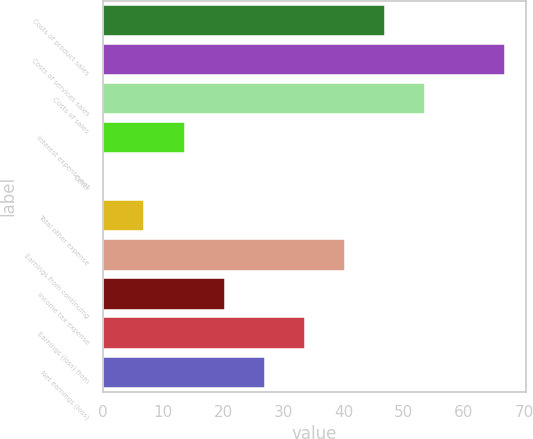<chart> <loc_0><loc_0><loc_500><loc_500><bar_chart><fcel>Costs of product sales<fcel>Costs of services sales<fcel>Costs of sales<fcel>Interest expense net<fcel>Other<fcel>Total other expense<fcel>Earnings from continuing<fcel>Income tax expense<fcel>Earnings (loss) from<fcel>Net earnings (loss)<nl><fcel>46.89<fcel>66.9<fcel>53.56<fcel>13.54<fcel>0.2<fcel>6.87<fcel>40.22<fcel>20.21<fcel>33.55<fcel>26.88<nl></chart> 